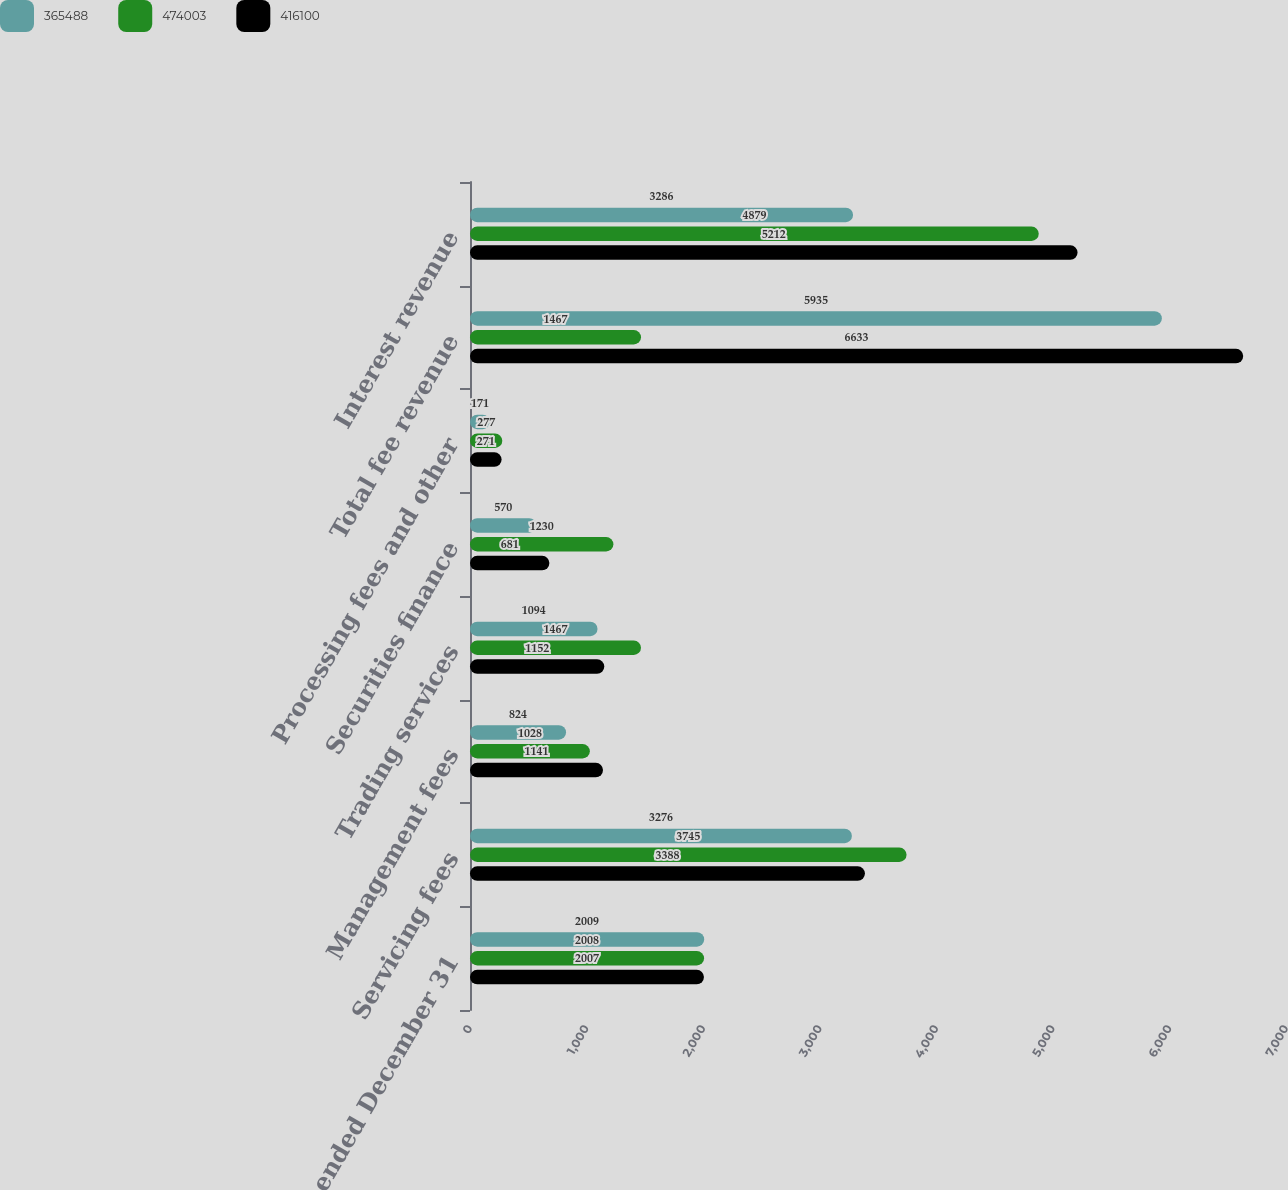<chart> <loc_0><loc_0><loc_500><loc_500><stacked_bar_chart><ecel><fcel>Years ended December 31<fcel>Servicing fees<fcel>Management fees<fcel>Trading services<fcel>Securities finance<fcel>Processing fees and other<fcel>Total fee revenue<fcel>Interest revenue<nl><fcel>365488<fcel>2009<fcel>3276<fcel>824<fcel>1094<fcel>570<fcel>171<fcel>5935<fcel>3286<nl><fcel>474003<fcel>2008<fcel>3745<fcel>1028<fcel>1467<fcel>1230<fcel>277<fcel>1467<fcel>4879<nl><fcel>416100<fcel>2007<fcel>3388<fcel>1141<fcel>1152<fcel>681<fcel>271<fcel>6633<fcel>5212<nl></chart> 